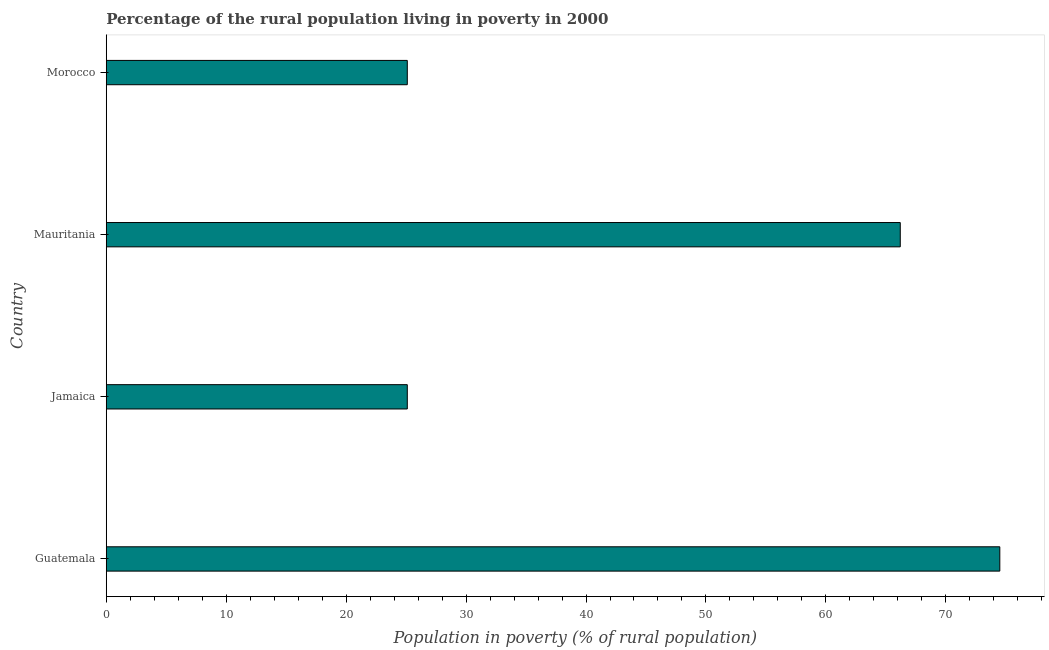Does the graph contain any zero values?
Keep it short and to the point. No. What is the title of the graph?
Offer a very short reply. Percentage of the rural population living in poverty in 2000. What is the label or title of the X-axis?
Your answer should be very brief. Population in poverty (% of rural population). What is the percentage of rural population living below poverty line in Morocco?
Offer a terse response. 25.1. Across all countries, what is the maximum percentage of rural population living below poverty line?
Keep it short and to the point. 74.5. Across all countries, what is the minimum percentage of rural population living below poverty line?
Provide a short and direct response. 25.1. In which country was the percentage of rural population living below poverty line maximum?
Offer a very short reply. Guatemala. In which country was the percentage of rural population living below poverty line minimum?
Your answer should be very brief. Jamaica. What is the sum of the percentage of rural population living below poverty line?
Offer a terse response. 190.9. What is the average percentage of rural population living below poverty line per country?
Your answer should be very brief. 47.73. What is the median percentage of rural population living below poverty line?
Provide a succinct answer. 45.65. What is the ratio of the percentage of rural population living below poverty line in Mauritania to that in Morocco?
Your answer should be very brief. 2.64. What is the difference between the highest and the second highest percentage of rural population living below poverty line?
Provide a succinct answer. 8.3. What is the difference between the highest and the lowest percentage of rural population living below poverty line?
Offer a very short reply. 49.4. How many bars are there?
Your answer should be very brief. 4. How many countries are there in the graph?
Your answer should be very brief. 4. Are the values on the major ticks of X-axis written in scientific E-notation?
Provide a short and direct response. No. What is the Population in poverty (% of rural population) in Guatemala?
Give a very brief answer. 74.5. What is the Population in poverty (% of rural population) in Jamaica?
Ensure brevity in your answer.  25.1. What is the Population in poverty (% of rural population) of Mauritania?
Offer a very short reply. 66.2. What is the Population in poverty (% of rural population) of Morocco?
Provide a succinct answer. 25.1. What is the difference between the Population in poverty (% of rural population) in Guatemala and Jamaica?
Your response must be concise. 49.4. What is the difference between the Population in poverty (% of rural population) in Guatemala and Mauritania?
Ensure brevity in your answer.  8.3. What is the difference between the Population in poverty (% of rural population) in Guatemala and Morocco?
Offer a very short reply. 49.4. What is the difference between the Population in poverty (% of rural population) in Jamaica and Mauritania?
Your response must be concise. -41.1. What is the difference between the Population in poverty (% of rural population) in Jamaica and Morocco?
Make the answer very short. 0. What is the difference between the Population in poverty (% of rural population) in Mauritania and Morocco?
Give a very brief answer. 41.1. What is the ratio of the Population in poverty (% of rural population) in Guatemala to that in Jamaica?
Ensure brevity in your answer.  2.97. What is the ratio of the Population in poverty (% of rural population) in Guatemala to that in Morocco?
Ensure brevity in your answer.  2.97. What is the ratio of the Population in poverty (% of rural population) in Jamaica to that in Mauritania?
Provide a succinct answer. 0.38. What is the ratio of the Population in poverty (% of rural population) in Jamaica to that in Morocco?
Provide a succinct answer. 1. What is the ratio of the Population in poverty (% of rural population) in Mauritania to that in Morocco?
Your answer should be compact. 2.64. 